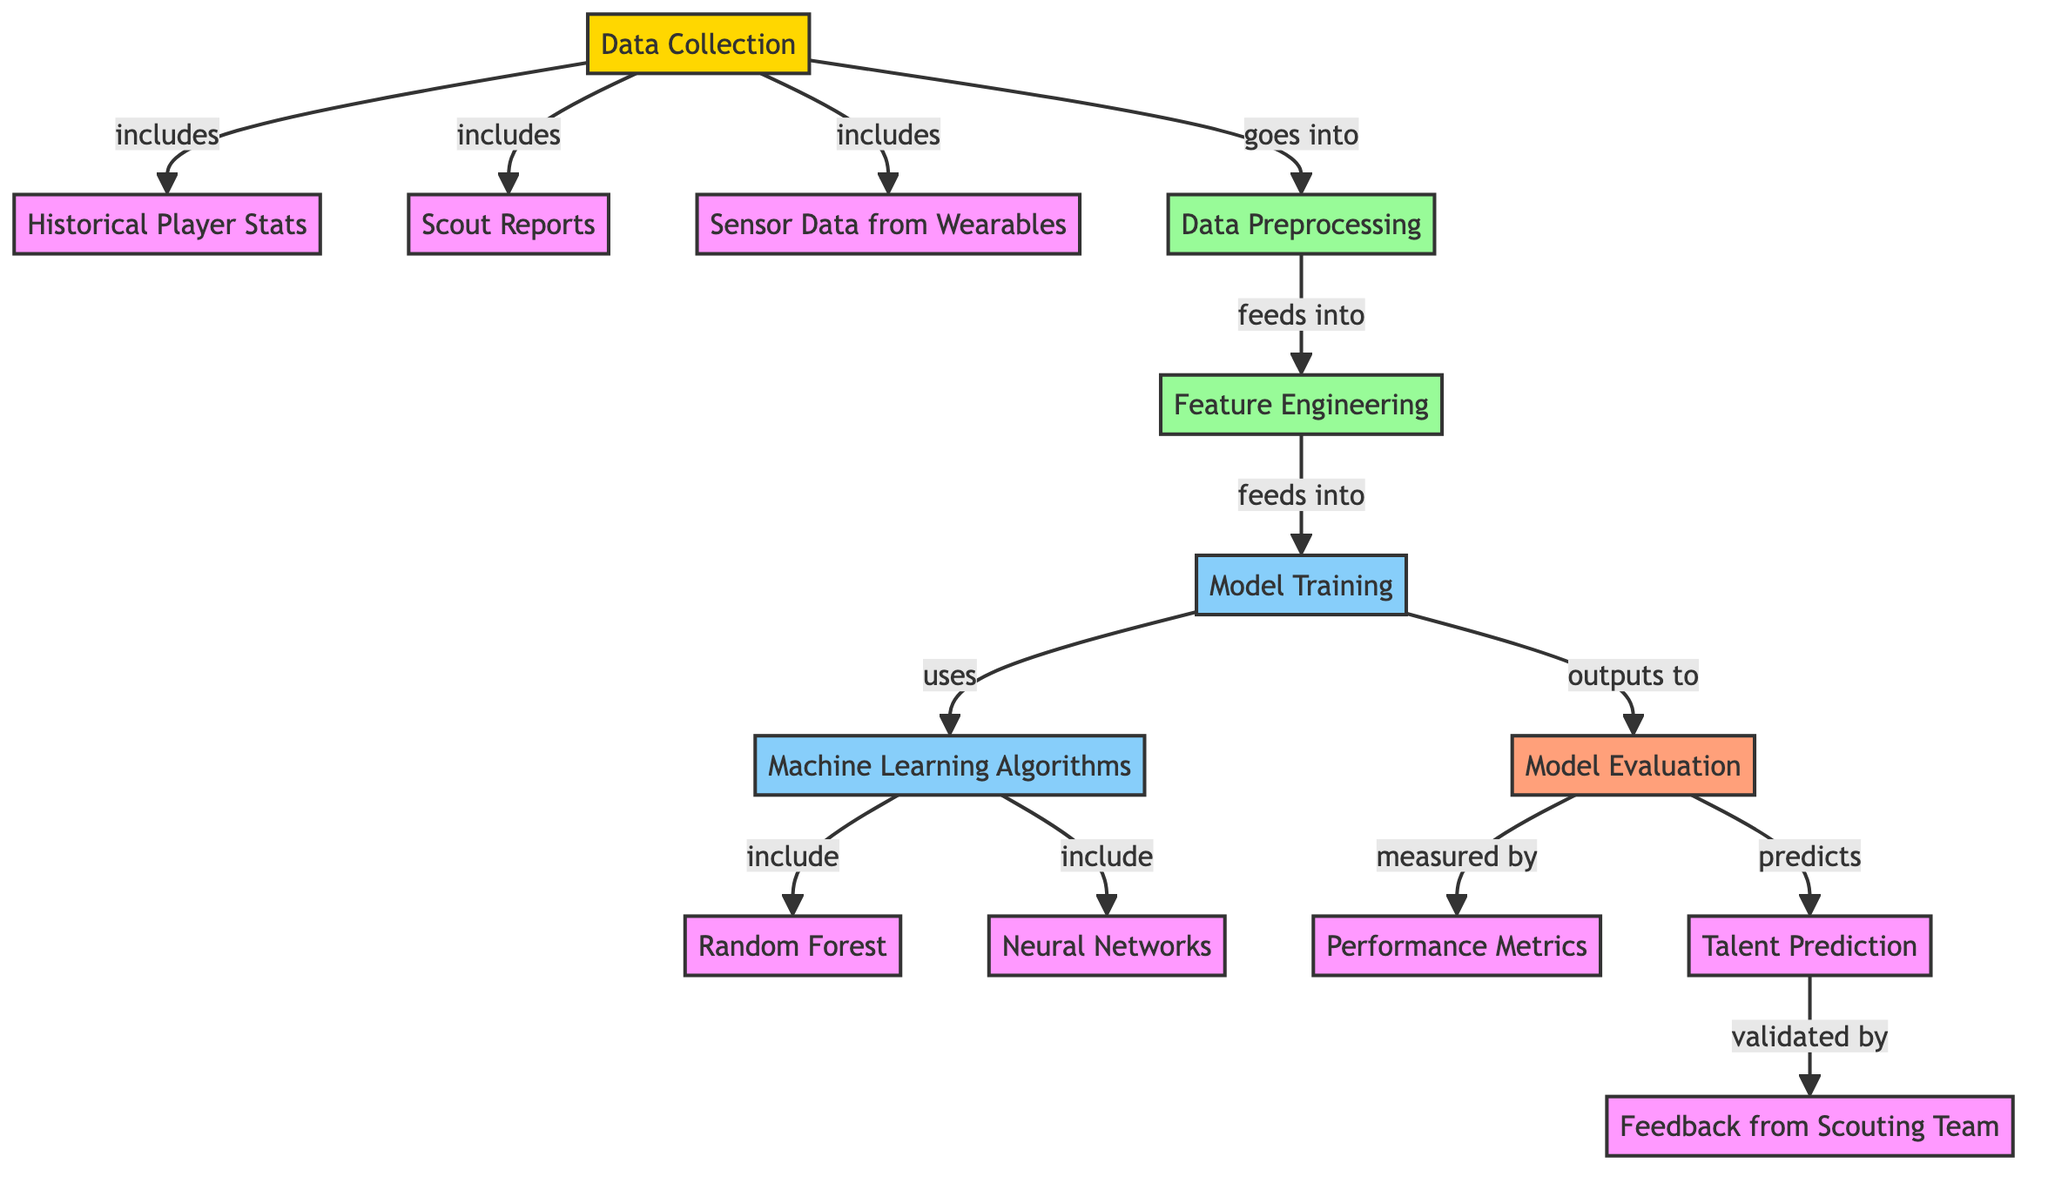What are the three data sources mentioned in the diagram? The diagram lists three specific data sources, which are historical player stats, scout reports, and sensor data from wearables.
Answer: historical player stats, scout reports, sensor data from wearables What node comes after data preprocessing? In the flow of the diagram, data preprocessing directly feeds into feature engineering, indicating it is the next step.
Answer: feature engineering How many machine learning algorithms are included in the model training? The diagram explicitly lists two machine learning algorithms: random forest and neural networks, which can be counted to provide the answer.
Answer: two What is the output of model training according to the diagram? According to the flow chart, the output of model training is funneled into model evaluation, showing that it is a necessary step after training.
Answer: model evaluation What is validated by the scouting team? The result of talent prediction is specified as being validated by the scouting team, indicating their role in confirming the predictions made.
Answer: talent prediction What role does feature engineering play in the diagram? Feature engineering serves as a key processing step that takes its input from data preprocessing and outputs to model training, highlighting its importance in preparing data for machine learning.
Answer: feeds into model training What measured the success of the model in the evaluation phase? Performance metrics are shown as the measure used to evaluate the model's effectiveness, indicating the criteria by which the model's predictions are assessed.
Answer: performance metrics How many steps are involved from data collection to talent prediction? By tracing the connections in the diagram, there are five distinct steps that lead from data collection to the final output of talent prediction, indicating a streamlined process.
Answer: five steps 